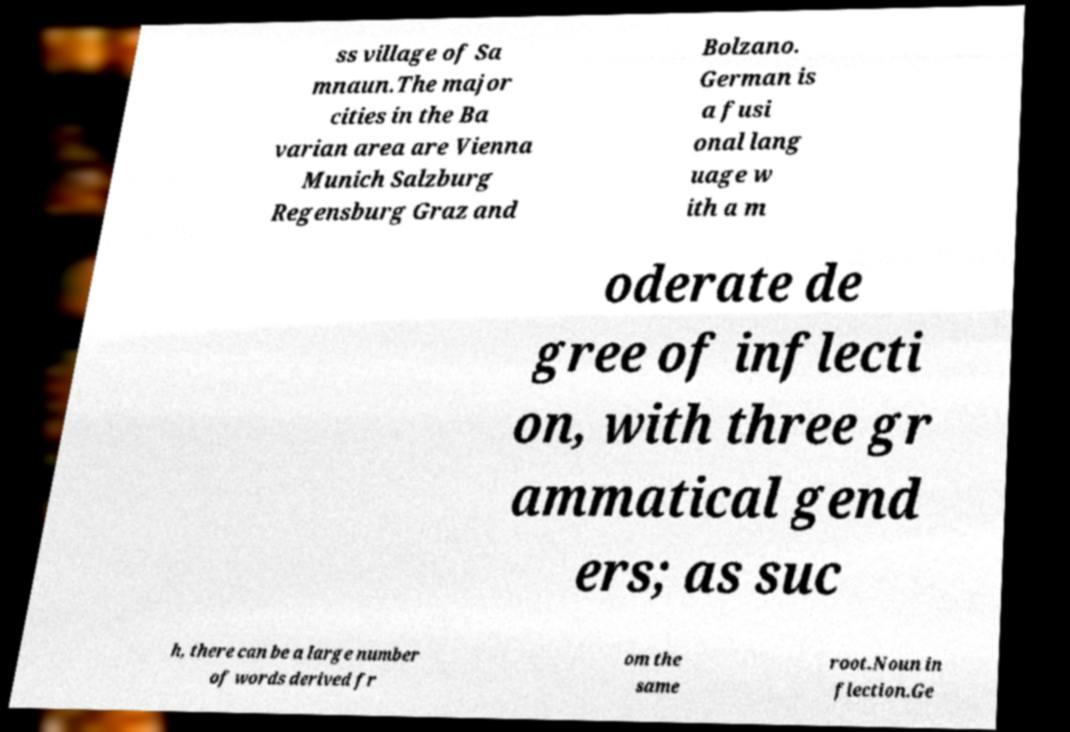Please identify and transcribe the text found in this image. ss village of Sa mnaun.The major cities in the Ba varian area are Vienna Munich Salzburg Regensburg Graz and Bolzano. German is a fusi onal lang uage w ith a m oderate de gree of inflecti on, with three gr ammatical gend ers; as suc h, there can be a large number of words derived fr om the same root.Noun in flection.Ge 